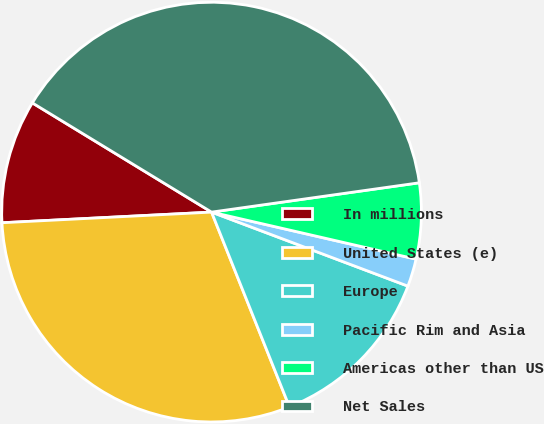<chart> <loc_0><loc_0><loc_500><loc_500><pie_chart><fcel>In millions<fcel>United States (e)<fcel>Europe<fcel>Pacific Rim and Asia<fcel>Americas other than US<fcel>Net Sales<nl><fcel>9.52%<fcel>30.25%<fcel>13.21%<fcel>2.14%<fcel>5.83%<fcel>39.06%<nl></chart> 